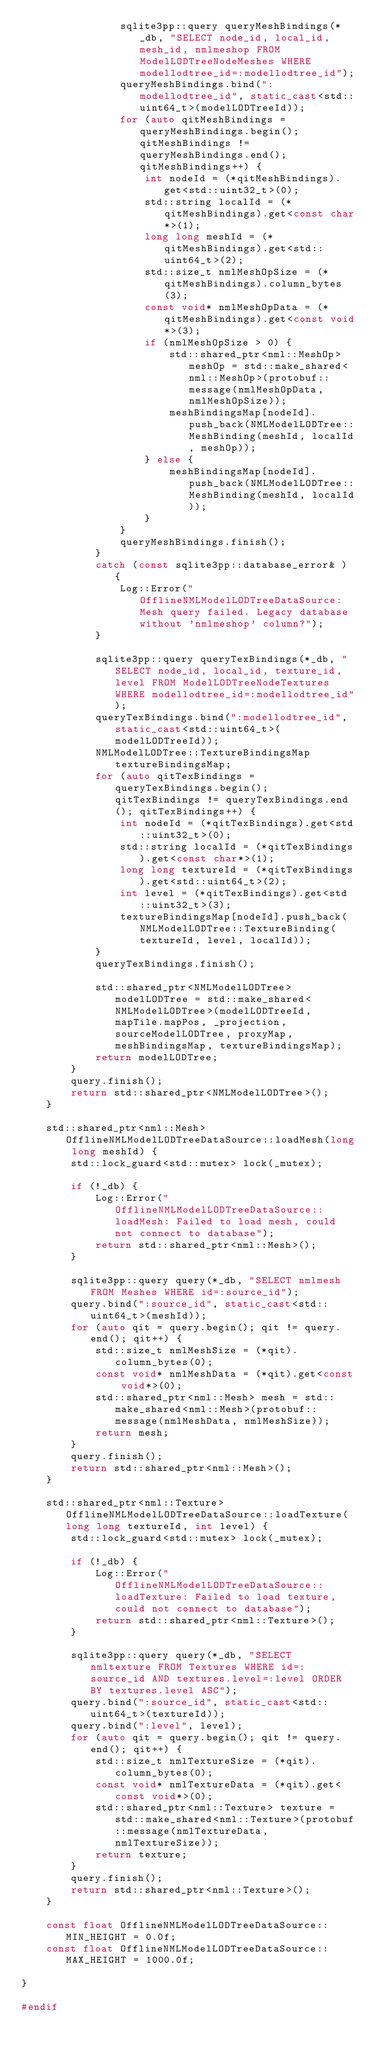<code> <loc_0><loc_0><loc_500><loc_500><_C++_>                sqlite3pp::query queryMeshBindings(*_db, "SELECT node_id, local_id, mesh_id, nmlmeshop FROM ModelLODTreeNodeMeshes WHERE modellodtree_id=:modellodtree_id");
                queryMeshBindings.bind(":modellodtree_id", static_cast<std::uint64_t>(modelLODTreeId));
                for (auto qitMeshBindings = queryMeshBindings.begin(); qitMeshBindings != queryMeshBindings.end(); qitMeshBindings++) {
                    int nodeId = (*qitMeshBindings).get<std::uint32_t>(0);
                    std::string localId = (*qitMeshBindings).get<const char*>(1);
                    long long meshId = (*qitMeshBindings).get<std::uint64_t>(2);
                    std::size_t nmlMeshOpSize = (*qitMeshBindings).column_bytes(3);
                    const void* nmlMeshOpData = (*qitMeshBindings).get<const void*>(3);
                    if (nmlMeshOpSize > 0) {
                        std::shared_ptr<nml::MeshOp> meshOp = std::make_shared<nml::MeshOp>(protobuf::message(nmlMeshOpData, nmlMeshOpSize));
                        meshBindingsMap[nodeId].push_back(NMLModelLODTree::MeshBinding(meshId, localId, meshOp));
                    } else {
                        meshBindingsMap[nodeId].push_back(NMLModelLODTree::MeshBinding(meshId, localId));
                    }
                }
                queryMeshBindings.finish();
            }
            catch (const sqlite3pp::database_error& ) {
                Log::Error("OfflineNMLModelLODTreeDataSource: Mesh query failed. Legacy database without 'nmlmeshop' column?");
            }
    
            sqlite3pp::query queryTexBindings(*_db, "SELECT node_id, local_id, texture_id, level FROM ModelLODTreeNodeTextures WHERE modellodtree_id=:modellodtree_id");
            queryTexBindings.bind(":modellodtree_id", static_cast<std::uint64_t>(modelLODTreeId));
            NMLModelLODTree::TextureBindingsMap textureBindingsMap;
            for (auto qitTexBindings = queryTexBindings.begin(); qitTexBindings != queryTexBindings.end(); qitTexBindings++) {
                int nodeId = (*qitTexBindings).get<std::uint32_t>(0);
                std::string localId = (*qitTexBindings).get<const char*>(1);
                long long textureId = (*qitTexBindings).get<std::uint64_t>(2);
                int level = (*qitTexBindings).get<std::uint32_t>(3);
                textureBindingsMap[nodeId].push_back(NMLModelLODTree::TextureBinding(textureId, level, localId));
            }
            queryTexBindings.finish();
    
            std::shared_ptr<NMLModelLODTree> modelLODTree = std::make_shared<NMLModelLODTree>(modelLODTreeId, mapTile.mapPos, _projection, sourceModelLODTree, proxyMap, meshBindingsMap, textureBindingsMap);
            return modelLODTree;
        }
        query.finish();
        return std::shared_ptr<NMLModelLODTree>();
    }
    
    std::shared_ptr<nml::Mesh> OfflineNMLModelLODTreeDataSource::loadMesh(long long meshId) {
        std::lock_guard<std::mutex> lock(_mutex);
    
        if (!_db) {
            Log::Error("OfflineNMLModelLODTreeDataSource::loadMesh: Failed to load mesh, could not connect to database");
            return std::shared_ptr<nml::Mesh>();
        }
    
        sqlite3pp::query query(*_db, "SELECT nmlmesh FROM Meshes WHERE id=:source_id");
        query.bind(":source_id", static_cast<std::uint64_t>(meshId));
        for (auto qit = query.begin(); qit != query.end(); qit++) {
            std::size_t nmlMeshSize = (*qit).column_bytes(0);
            const void* nmlMeshData = (*qit).get<const void*>(0);
            std::shared_ptr<nml::Mesh> mesh = std::make_shared<nml::Mesh>(protobuf::message(nmlMeshData, nmlMeshSize));
            return mesh;
        }
        query.finish();
        return std::shared_ptr<nml::Mesh>();
    }
    
    std::shared_ptr<nml::Texture> OfflineNMLModelLODTreeDataSource::loadTexture(long long textureId, int level) {
        std::lock_guard<std::mutex> lock(_mutex);
    
        if (!_db) {
            Log::Error("OfflineNMLModelLODTreeDataSource::loadTexture: Failed to load texture, could not connect to database");
            return std::shared_ptr<nml::Texture>();
        }
    
        sqlite3pp::query query(*_db, "SELECT nmltexture FROM Textures WHERE id=:source_id AND textures.level=:level ORDER BY textures.level ASC");
        query.bind(":source_id", static_cast<std::uint64_t>(textureId));
        query.bind(":level", level);
        for (auto qit = query.begin(); qit != query.end(); qit++) {
            std::size_t nmlTextureSize = (*qit).column_bytes(0);
            const void* nmlTextureData = (*qit).get<const void*>(0);
            std::shared_ptr<nml::Texture> texture = std::make_shared<nml::Texture>(protobuf::message(nmlTextureData, nmlTextureSize));
            return texture;
        }
        query.finish();
        return std::shared_ptr<nml::Texture>();
    }

    const float OfflineNMLModelLODTreeDataSource::MIN_HEIGHT = 0.0f;
    const float OfflineNMLModelLODTreeDataSource::MAX_HEIGHT = 1000.0f;
    
}

#endif
</code> 